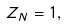Convert formula to latex. <formula><loc_0><loc_0><loc_500><loc_500>Z _ { N } = 1 ,</formula> 